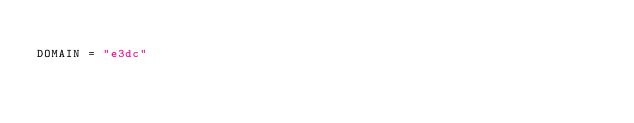Convert code to text. <code><loc_0><loc_0><loc_500><loc_500><_Python_>
DOMAIN = "e3dc"
</code> 